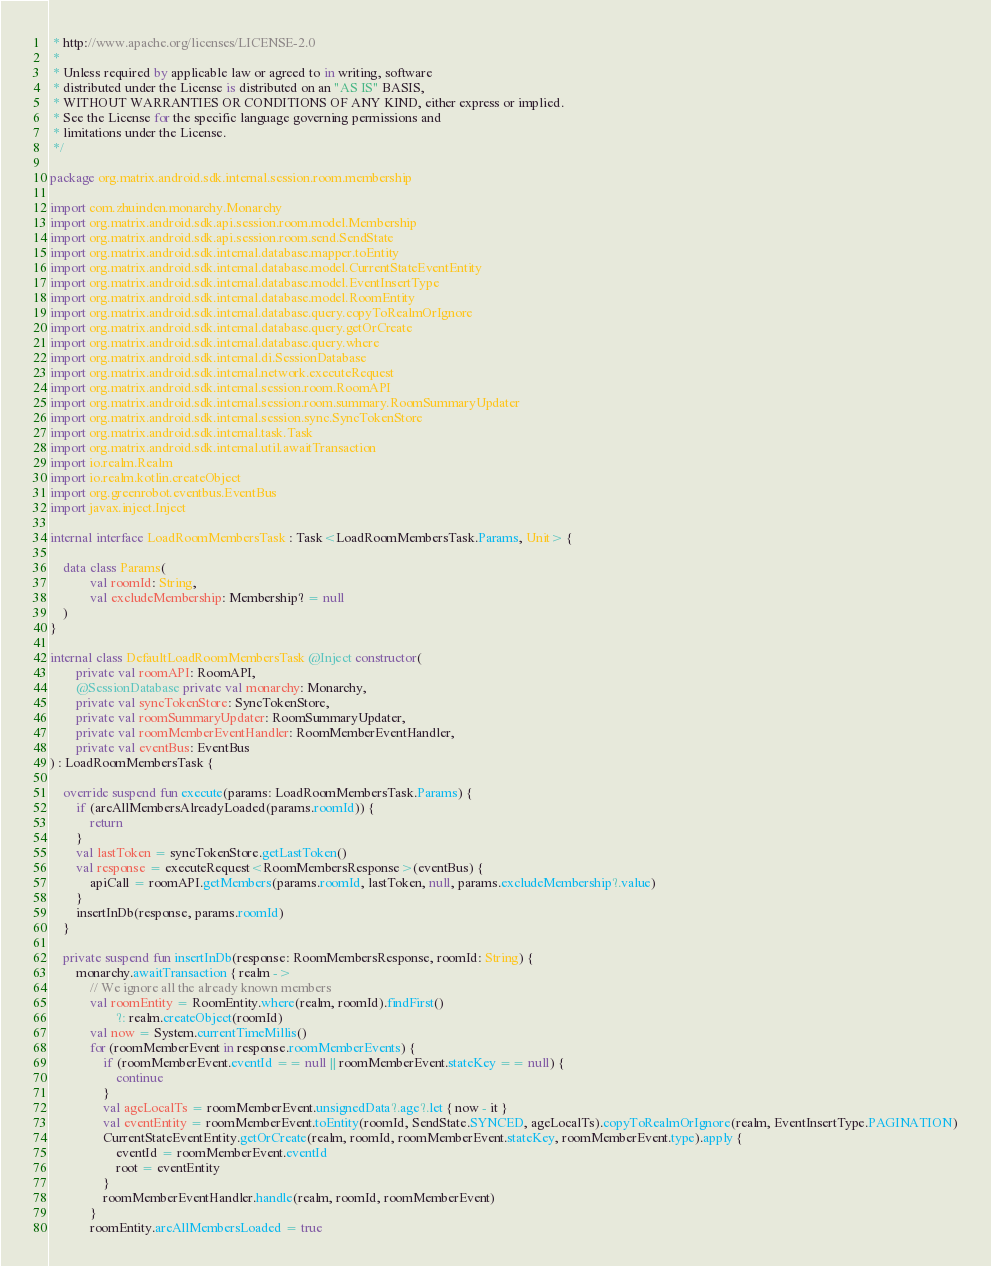<code> <loc_0><loc_0><loc_500><loc_500><_Kotlin_> * http://www.apache.org/licenses/LICENSE-2.0
 *
 * Unless required by applicable law or agreed to in writing, software
 * distributed under the License is distributed on an "AS IS" BASIS,
 * WITHOUT WARRANTIES OR CONDITIONS OF ANY KIND, either express or implied.
 * See the License for the specific language governing permissions and
 * limitations under the License.
 */

package org.matrix.android.sdk.internal.session.room.membership

import com.zhuinden.monarchy.Monarchy
import org.matrix.android.sdk.api.session.room.model.Membership
import org.matrix.android.sdk.api.session.room.send.SendState
import org.matrix.android.sdk.internal.database.mapper.toEntity
import org.matrix.android.sdk.internal.database.model.CurrentStateEventEntity
import org.matrix.android.sdk.internal.database.model.EventInsertType
import org.matrix.android.sdk.internal.database.model.RoomEntity
import org.matrix.android.sdk.internal.database.query.copyToRealmOrIgnore
import org.matrix.android.sdk.internal.database.query.getOrCreate
import org.matrix.android.sdk.internal.database.query.where
import org.matrix.android.sdk.internal.di.SessionDatabase
import org.matrix.android.sdk.internal.network.executeRequest
import org.matrix.android.sdk.internal.session.room.RoomAPI
import org.matrix.android.sdk.internal.session.room.summary.RoomSummaryUpdater
import org.matrix.android.sdk.internal.session.sync.SyncTokenStore
import org.matrix.android.sdk.internal.task.Task
import org.matrix.android.sdk.internal.util.awaitTransaction
import io.realm.Realm
import io.realm.kotlin.createObject
import org.greenrobot.eventbus.EventBus
import javax.inject.Inject

internal interface LoadRoomMembersTask : Task<LoadRoomMembersTask.Params, Unit> {

    data class Params(
            val roomId: String,
            val excludeMembership: Membership? = null
    )
}

internal class DefaultLoadRoomMembersTask @Inject constructor(
        private val roomAPI: RoomAPI,
        @SessionDatabase private val monarchy: Monarchy,
        private val syncTokenStore: SyncTokenStore,
        private val roomSummaryUpdater: RoomSummaryUpdater,
        private val roomMemberEventHandler: RoomMemberEventHandler,
        private val eventBus: EventBus
) : LoadRoomMembersTask {

    override suspend fun execute(params: LoadRoomMembersTask.Params) {
        if (areAllMembersAlreadyLoaded(params.roomId)) {
            return
        }
        val lastToken = syncTokenStore.getLastToken()
        val response = executeRequest<RoomMembersResponse>(eventBus) {
            apiCall = roomAPI.getMembers(params.roomId, lastToken, null, params.excludeMembership?.value)
        }
        insertInDb(response, params.roomId)
    }

    private suspend fun insertInDb(response: RoomMembersResponse, roomId: String) {
        monarchy.awaitTransaction { realm ->
            // We ignore all the already known members
            val roomEntity = RoomEntity.where(realm, roomId).findFirst()
                    ?: realm.createObject(roomId)
            val now = System.currentTimeMillis()
            for (roomMemberEvent in response.roomMemberEvents) {
                if (roomMemberEvent.eventId == null || roomMemberEvent.stateKey == null) {
                    continue
                }
                val ageLocalTs = roomMemberEvent.unsignedData?.age?.let { now - it }
                val eventEntity = roomMemberEvent.toEntity(roomId, SendState.SYNCED, ageLocalTs).copyToRealmOrIgnore(realm, EventInsertType.PAGINATION)
                CurrentStateEventEntity.getOrCreate(realm, roomId, roomMemberEvent.stateKey, roomMemberEvent.type).apply {
                    eventId = roomMemberEvent.eventId
                    root = eventEntity
                }
                roomMemberEventHandler.handle(realm, roomId, roomMemberEvent)
            }
            roomEntity.areAllMembersLoaded = true</code> 